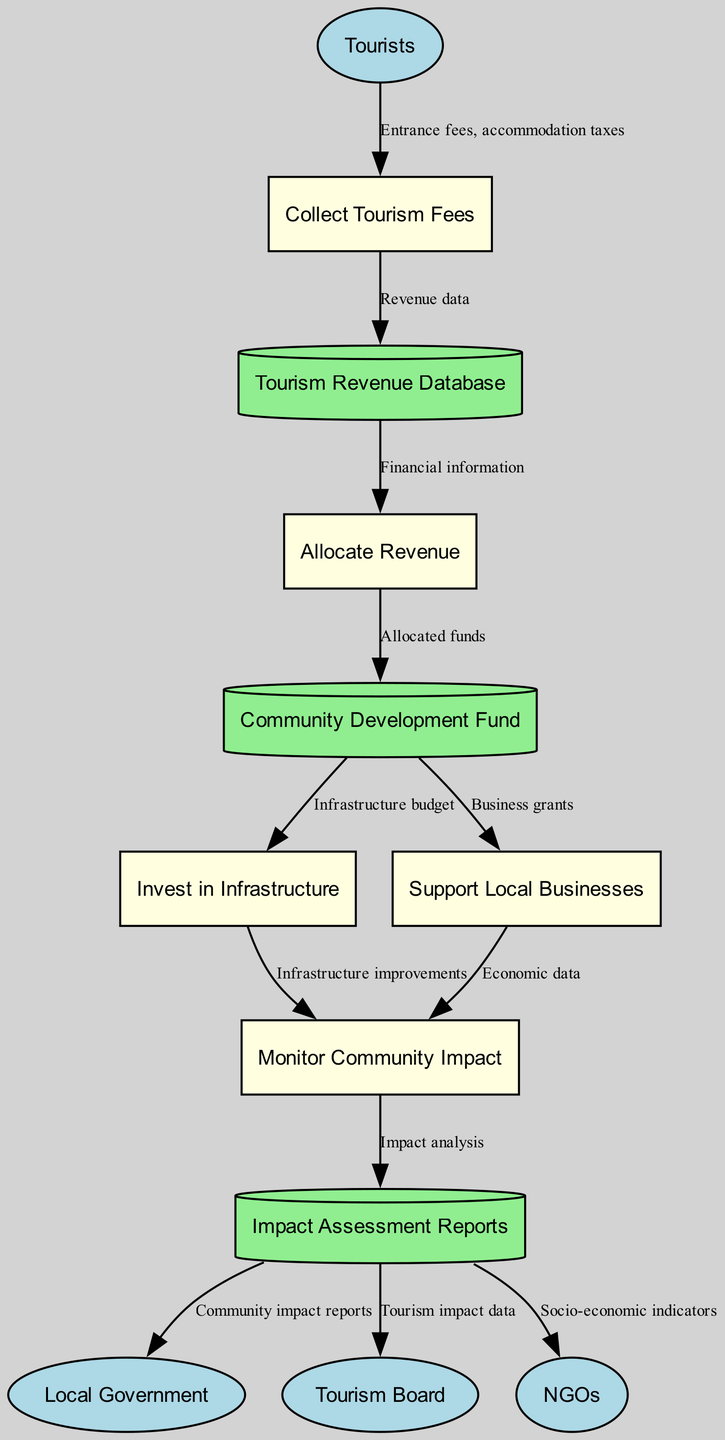What are the external entities involved in the diagram? The external entities listed in the diagram are found in a specific section, providing basic information about the parties interacting with the processes. They include "Tourists," "Local Government," "Tourism Board," and "NGOs."
Answer: Tourists, Local Government, Tourism Board, NGOs How many processes are there in the diagram? The processes are represented within a distinct area of the diagram, and a count of them reveals there are five listed processes concerning tourism revenue distribution.
Answer: 5 What data flows from "Collect Tourism Fees" to "Tourism Revenue Database"? The diagram depicts that the "Collect Tourism Fees" process sends "Revenue data" to the "Tourism Revenue Database," defining the flow of information.
Answer: Revenue data Which data store receives "Allocated funds"? Following the flow from "Allocate Revenue" in the diagram, the "Community Development Fund" is the designated data store that receives the "Allocated funds."
Answer: Community Development Fund What is the relationship between "Invest in Infrastructure" and "Monitor Community Impact"? The flow indicates that "Invest in Infrastructure" feeds into "Monitor Community Impact" through "Infrastructure improvements," highlighting the dependent relationship between these two processes.
Answer: Infrastructure improvements What type of report is sent to the Local Government? The diagram illustrates that the "Impact Assessment Reports" contain "Community impact reports," which are then sent to the Local Government, depicting their significance.
Answer: Community impact reports Which entities receive information from "Impact Assessment Reports"? The diagram shows multiple arrows from "Impact Assessment Reports" to three entities: "Local Government," "Tourism Board," and "NGOs," indicating that these entities receive various data.
Answer: Local Government, Tourism Board, NGOs What is the first step in the tourism revenue distribution process? By analyzing the flow in the diagram, the first process is identified as "Collect Tourism Fees," marking the initiation of the revenue distribution procedure.
Answer: Collect Tourism Fees How does the diagram represent the flow of data regarding local business support? The flow from "Community Development Fund" to "Support Local Businesses" represents the allocation of resources, where "Business grants" are provided, detailing how local businesses are supported.
Answer: Business grants 